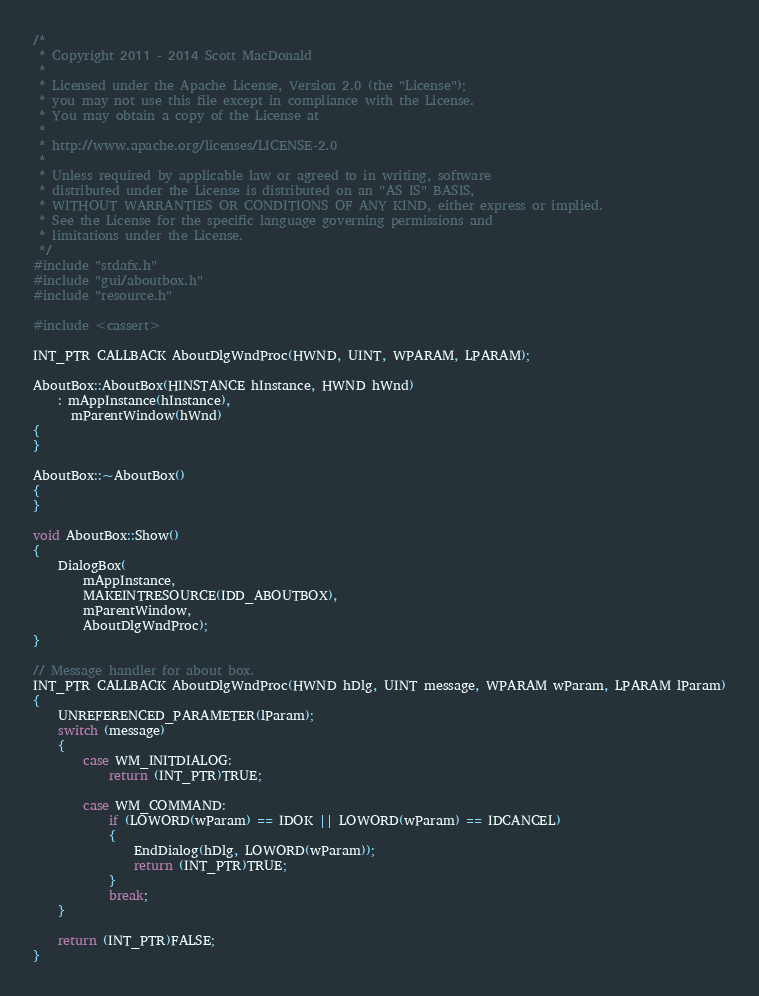Convert code to text. <code><loc_0><loc_0><loc_500><loc_500><_C++_>/*
 * Copyright 2011 - 2014 Scott MacDonald
 *
 * Licensed under the Apache License, Version 2.0 (the "License");
 * you may not use this file except in compliance with the License.
 * You may obtain a copy of the License at
 *
 * http://www.apache.org/licenses/LICENSE-2.0
 *
 * Unless required by applicable law or agreed to in writing, software
 * distributed under the License is distributed on an "AS IS" BASIS,
 * WITHOUT WARRANTIES OR CONDITIONS OF ANY KIND, either express or implied.
 * See the License for the specific language governing permissions and
 * limitations under the License.
 */
#include "stdafx.h"
#include "gui/aboutbox.h"
#include "resource.h"

#include <cassert>

INT_PTR CALLBACK AboutDlgWndProc(HWND, UINT, WPARAM, LPARAM);

AboutBox::AboutBox(HINSTANCE hInstance, HWND hWnd)
    : mAppInstance(hInstance),
      mParentWindow(hWnd)
{
}

AboutBox::~AboutBox()
{
}

void AboutBox::Show()
{
    DialogBox(
        mAppInstance,
        MAKEINTRESOURCE(IDD_ABOUTBOX),
        mParentWindow,
        AboutDlgWndProc);
}

// Message handler for about box.
INT_PTR CALLBACK AboutDlgWndProc(HWND hDlg, UINT message, WPARAM wParam, LPARAM lParam)
{
    UNREFERENCED_PARAMETER(lParam);
    switch (message)
    {
        case WM_INITDIALOG:
            return (INT_PTR)TRUE;

        case WM_COMMAND:
            if (LOWORD(wParam) == IDOK || LOWORD(wParam) == IDCANCEL)
            {
                EndDialog(hDlg, LOWORD(wParam));
                return (INT_PTR)TRUE;
            }
            break;
    }

    return (INT_PTR)FALSE;
}</code> 